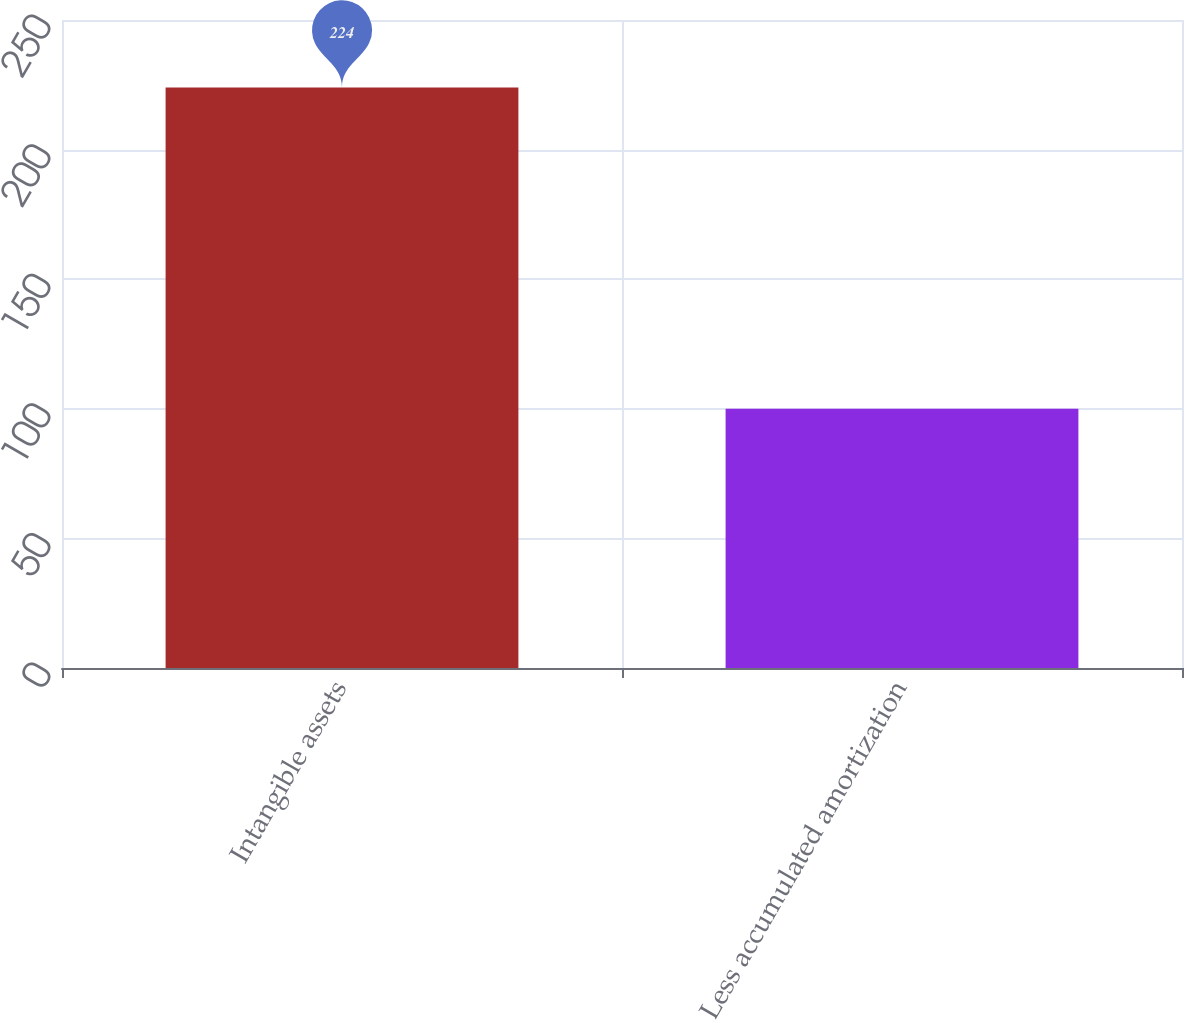<chart> <loc_0><loc_0><loc_500><loc_500><bar_chart><fcel>Intangible assets<fcel>Less accumulated amortization<nl><fcel>224<fcel>100<nl></chart> 